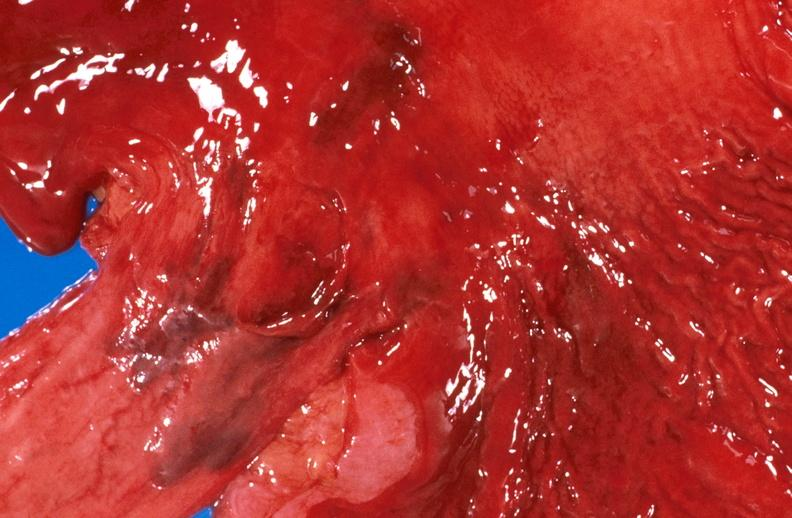where does this belong to?
Answer the question using a single word or phrase. Gastrointestinal system 